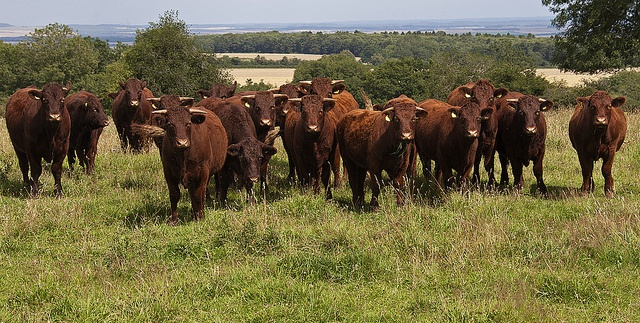Describe the objects in this image and their specific colors. I can see cow in lightgray, black, maroon, and brown tones, cow in lightgray, black, maroon, and brown tones, cow in lightgray, black, maroon, and brown tones, cow in lightgray, black, maroon, and brown tones, and cow in lightgray, black, maroon, and brown tones in this image. 